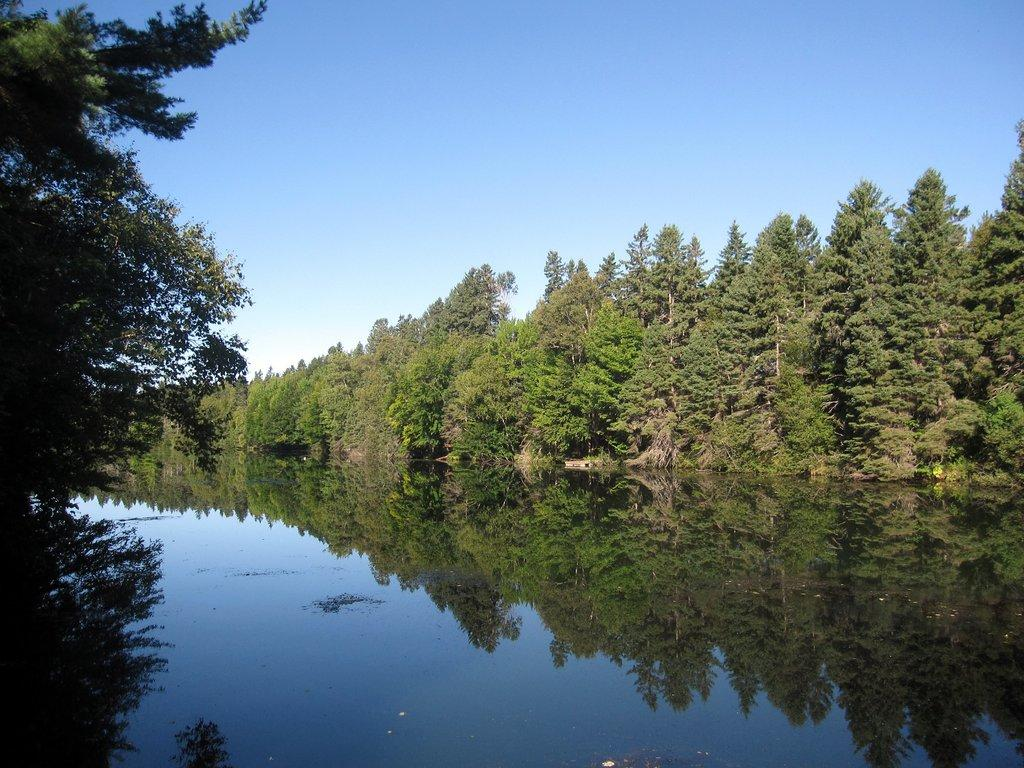What is one of the main elements in the image? There is water in the image. What else can be seen in the image besides water? There are trees and the sky visible in the image. Can you describe the reflection in the water? The reflection of the trees and the sky is visible in the water. Where is the family sitting in the image? There is no family present in the image. Can you describe the size and shape of the bulb in the image? There is no bulb present in the image. 